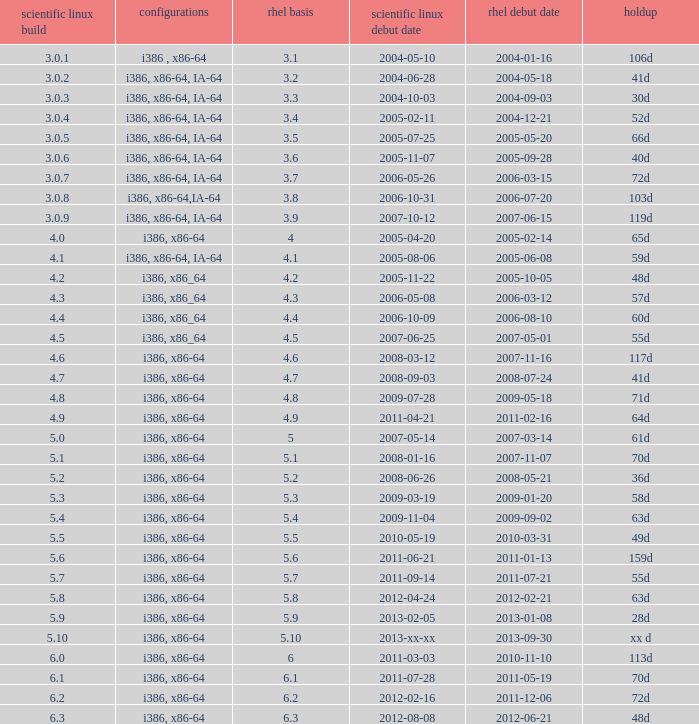Name the delay when scientific linux release is 5.10 Xx d. 